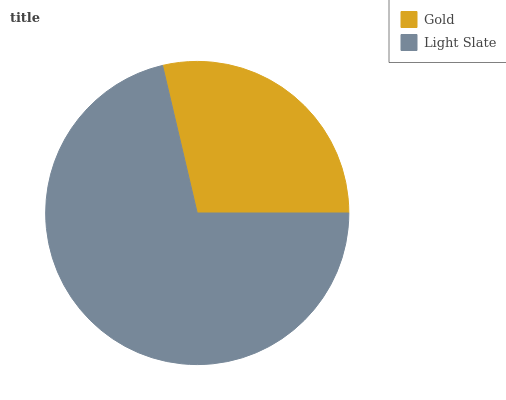Is Gold the minimum?
Answer yes or no. Yes. Is Light Slate the maximum?
Answer yes or no. Yes. Is Light Slate the minimum?
Answer yes or no. No. Is Light Slate greater than Gold?
Answer yes or no. Yes. Is Gold less than Light Slate?
Answer yes or no. Yes. Is Gold greater than Light Slate?
Answer yes or no. No. Is Light Slate less than Gold?
Answer yes or no. No. Is Light Slate the high median?
Answer yes or no. Yes. Is Gold the low median?
Answer yes or no. Yes. Is Gold the high median?
Answer yes or no. No. Is Light Slate the low median?
Answer yes or no. No. 